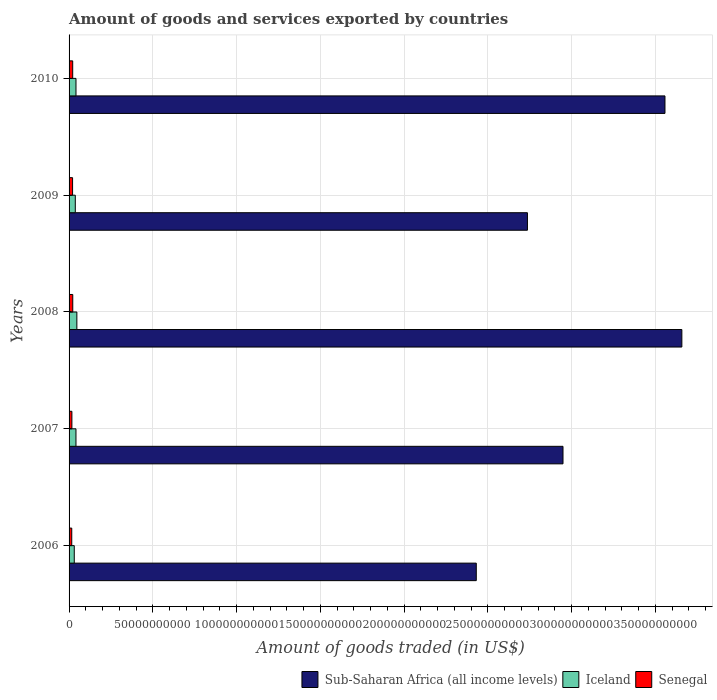How many different coloured bars are there?
Keep it short and to the point. 3. How many groups of bars are there?
Ensure brevity in your answer.  5. Are the number of bars per tick equal to the number of legend labels?
Keep it short and to the point. Yes. Are the number of bars on each tick of the Y-axis equal?
Ensure brevity in your answer.  Yes. How many bars are there on the 1st tick from the top?
Ensure brevity in your answer.  3. How many bars are there on the 5th tick from the bottom?
Offer a terse response. 3. What is the label of the 3rd group of bars from the top?
Make the answer very short. 2008. In how many cases, is the number of bars for a given year not equal to the number of legend labels?
Offer a very short reply. 0. What is the total amount of goods and services exported in Senegal in 2007?
Your response must be concise. 1.68e+09. Across all years, what is the maximum total amount of goods and services exported in Sub-Saharan Africa (all income levels)?
Offer a terse response. 3.66e+11. Across all years, what is the minimum total amount of goods and services exported in Iceland?
Give a very brief answer. 3.10e+09. What is the total total amount of goods and services exported in Senegal in the graph?
Keep it short and to the point. 9.75e+09. What is the difference between the total amount of goods and services exported in Iceland in 2009 and that in 2010?
Keep it short and to the point. -4.06e+08. What is the difference between the total amount of goods and services exported in Senegal in 2006 and the total amount of goods and services exported in Sub-Saharan Africa (all income levels) in 2007?
Give a very brief answer. -2.93e+11. What is the average total amount of goods and services exported in Senegal per year?
Make the answer very short. 1.95e+09. In the year 2010, what is the difference between the total amount of goods and services exported in Iceland and total amount of goods and services exported in Senegal?
Your answer should be very brief. 1.96e+09. In how many years, is the total amount of goods and services exported in Iceland greater than 20000000000 US$?
Ensure brevity in your answer.  0. What is the ratio of the total amount of goods and services exported in Senegal in 2006 to that in 2008?
Provide a succinct answer. 0.72. Is the total amount of goods and services exported in Iceland in 2009 less than that in 2010?
Ensure brevity in your answer.  Yes. What is the difference between the highest and the second highest total amount of goods and services exported in Senegal?
Offer a terse response. 4.41e+07. What is the difference between the highest and the lowest total amount of goods and services exported in Iceland?
Offer a very short reply. 1.55e+09. In how many years, is the total amount of goods and services exported in Senegal greater than the average total amount of goods and services exported in Senegal taken over all years?
Give a very brief answer. 3. Is the sum of the total amount of goods and services exported in Senegal in 2008 and 2010 greater than the maximum total amount of goods and services exported in Sub-Saharan Africa (all income levels) across all years?
Offer a very short reply. No. What does the 3rd bar from the top in 2008 represents?
Offer a very short reply. Sub-Saharan Africa (all income levels). What does the 2nd bar from the bottom in 2010 represents?
Provide a succinct answer. Iceland. Is it the case that in every year, the sum of the total amount of goods and services exported in Sub-Saharan Africa (all income levels) and total amount of goods and services exported in Iceland is greater than the total amount of goods and services exported in Senegal?
Give a very brief answer. Yes. How many bars are there?
Your response must be concise. 15. Are all the bars in the graph horizontal?
Provide a succinct answer. Yes. How many years are there in the graph?
Your response must be concise. 5. Does the graph contain any zero values?
Keep it short and to the point. No. Does the graph contain grids?
Provide a succinct answer. Yes. Where does the legend appear in the graph?
Ensure brevity in your answer.  Bottom right. How many legend labels are there?
Make the answer very short. 3. How are the legend labels stacked?
Offer a terse response. Horizontal. What is the title of the graph?
Give a very brief answer. Amount of goods and services exported by countries. What is the label or title of the X-axis?
Provide a short and direct response. Amount of goods traded (in US$). What is the Amount of goods traded (in US$) of Sub-Saharan Africa (all income levels) in 2006?
Your answer should be very brief. 2.43e+11. What is the Amount of goods traded (in US$) of Iceland in 2006?
Your answer should be compact. 3.10e+09. What is the Amount of goods traded (in US$) in Senegal in 2006?
Your response must be concise. 1.60e+09. What is the Amount of goods traded (in US$) in Sub-Saharan Africa (all income levels) in 2007?
Ensure brevity in your answer.  2.95e+11. What is the Amount of goods traded (in US$) in Iceland in 2007?
Your response must be concise. 4.12e+09. What is the Amount of goods traded (in US$) of Senegal in 2007?
Your answer should be compact. 1.68e+09. What is the Amount of goods traded (in US$) in Sub-Saharan Africa (all income levels) in 2008?
Keep it short and to the point. 3.66e+11. What is the Amount of goods traded (in US$) in Iceland in 2008?
Your response must be concise. 4.65e+09. What is the Amount of goods traded (in US$) of Senegal in 2008?
Your response must be concise. 2.21e+09. What is the Amount of goods traded (in US$) of Sub-Saharan Africa (all income levels) in 2009?
Your answer should be compact. 2.74e+11. What is the Amount of goods traded (in US$) in Iceland in 2009?
Your response must be concise. 3.72e+09. What is the Amount of goods traded (in US$) in Senegal in 2009?
Ensure brevity in your answer.  2.10e+09. What is the Amount of goods traded (in US$) of Sub-Saharan Africa (all income levels) in 2010?
Make the answer very short. 3.56e+11. What is the Amount of goods traded (in US$) in Iceland in 2010?
Ensure brevity in your answer.  4.12e+09. What is the Amount of goods traded (in US$) in Senegal in 2010?
Offer a terse response. 2.16e+09. Across all years, what is the maximum Amount of goods traded (in US$) in Sub-Saharan Africa (all income levels)?
Keep it short and to the point. 3.66e+11. Across all years, what is the maximum Amount of goods traded (in US$) in Iceland?
Offer a very short reply. 4.65e+09. Across all years, what is the maximum Amount of goods traded (in US$) in Senegal?
Make the answer very short. 2.21e+09. Across all years, what is the minimum Amount of goods traded (in US$) of Sub-Saharan Africa (all income levels)?
Your response must be concise. 2.43e+11. Across all years, what is the minimum Amount of goods traded (in US$) in Iceland?
Give a very brief answer. 3.10e+09. Across all years, what is the minimum Amount of goods traded (in US$) in Senegal?
Offer a terse response. 1.60e+09. What is the total Amount of goods traded (in US$) of Sub-Saharan Africa (all income levels) in the graph?
Your answer should be compact. 1.53e+12. What is the total Amount of goods traded (in US$) of Iceland in the graph?
Your response must be concise. 1.97e+1. What is the total Amount of goods traded (in US$) of Senegal in the graph?
Provide a succinct answer. 9.75e+09. What is the difference between the Amount of goods traded (in US$) of Sub-Saharan Africa (all income levels) in 2006 and that in 2007?
Give a very brief answer. -5.18e+1. What is the difference between the Amount of goods traded (in US$) of Iceland in 2006 and that in 2007?
Your answer should be very brief. -1.02e+09. What is the difference between the Amount of goods traded (in US$) of Senegal in 2006 and that in 2007?
Give a very brief answer. -8.17e+07. What is the difference between the Amount of goods traded (in US$) in Sub-Saharan Africa (all income levels) in 2006 and that in 2008?
Your answer should be compact. -1.23e+11. What is the difference between the Amount of goods traded (in US$) of Iceland in 2006 and that in 2008?
Your answer should be very brief. -1.55e+09. What is the difference between the Amount of goods traded (in US$) in Senegal in 2006 and that in 2008?
Ensure brevity in your answer.  -6.09e+08. What is the difference between the Amount of goods traded (in US$) in Sub-Saharan Africa (all income levels) in 2006 and that in 2009?
Your answer should be very brief. -3.05e+1. What is the difference between the Amount of goods traded (in US$) of Iceland in 2006 and that in 2009?
Your answer should be compact. -6.17e+08. What is the difference between the Amount of goods traded (in US$) of Senegal in 2006 and that in 2009?
Your answer should be compact. -4.97e+08. What is the difference between the Amount of goods traded (in US$) of Sub-Saharan Africa (all income levels) in 2006 and that in 2010?
Make the answer very short. -1.13e+11. What is the difference between the Amount of goods traded (in US$) in Iceland in 2006 and that in 2010?
Offer a terse response. -1.02e+09. What is the difference between the Amount of goods traded (in US$) of Senegal in 2006 and that in 2010?
Ensure brevity in your answer.  -5.64e+08. What is the difference between the Amount of goods traded (in US$) in Sub-Saharan Africa (all income levels) in 2007 and that in 2008?
Ensure brevity in your answer.  -7.09e+1. What is the difference between the Amount of goods traded (in US$) in Iceland in 2007 and that in 2008?
Keep it short and to the point. -5.34e+08. What is the difference between the Amount of goods traded (in US$) of Senegal in 2007 and that in 2008?
Your answer should be compact. -5.27e+08. What is the difference between the Amount of goods traded (in US$) in Sub-Saharan Africa (all income levels) in 2007 and that in 2009?
Offer a terse response. 2.12e+1. What is the difference between the Amount of goods traded (in US$) in Iceland in 2007 and that in 2009?
Your answer should be very brief. 4.02e+08. What is the difference between the Amount of goods traded (in US$) of Senegal in 2007 and that in 2009?
Give a very brief answer. -4.15e+08. What is the difference between the Amount of goods traded (in US$) of Sub-Saharan Africa (all income levels) in 2007 and that in 2010?
Offer a very short reply. -6.09e+1. What is the difference between the Amount of goods traded (in US$) in Iceland in 2007 and that in 2010?
Provide a succinct answer. -3.23e+06. What is the difference between the Amount of goods traded (in US$) in Senegal in 2007 and that in 2010?
Keep it short and to the point. -4.83e+08. What is the difference between the Amount of goods traded (in US$) in Sub-Saharan Africa (all income levels) in 2008 and that in 2009?
Keep it short and to the point. 9.22e+1. What is the difference between the Amount of goods traded (in US$) of Iceland in 2008 and that in 2009?
Offer a terse response. 9.37e+08. What is the difference between the Amount of goods traded (in US$) of Senegal in 2008 and that in 2009?
Offer a terse response. 1.12e+08. What is the difference between the Amount of goods traded (in US$) of Sub-Saharan Africa (all income levels) in 2008 and that in 2010?
Provide a succinct answer. 1.01e+1. What is the difference between the Amount of goods traded (in US$) in Iceland in 2008 and that in 2010?
Provide a short and direct response. 5.31e+08. What is the difference between the Amount of goods traded (in US$) of Senegal in 2008 and that in 2010?
Make the answer very short. 4.41e+07. What is the difference between the Amount of goods traded (in US$) of Sub-Saharan Africa (all income levels) in 2009 and that in 2010?
Ensure brevity in your answer.  -8.21e+1. What is the difference between the Amount of goods traded (in US$) in Iceland in 2009 and that in 2010?
Provide a succinct answer. -4.06e+08. What is the difference between the Amount of goods traded (in US$) in Senegal in 2009 and that in 2010?
Make the answer very short. -6.74e+07. What is the difference between the Amount of goods traded (in US$) in Sub-Saharan Africa (all income levels) in 2006 and the Amount of goods traded (in US$) in Iceland in 2007?
Provide a short and direct response. 2.39e+11. What is the difference between the Amount of goods traded (in US$) of Sub-Saharan Africa (all income levels) in 2006 and the Amount of goods traded (in US$) of Senegal in 2007?
Offer a terse response. 2.41e+11. What is the difference between the Amount of goods traded (in US$) in Iceland in 2006 and the Amount of goods traded (in US$) in Senegal in 2007?
Give a very brief answer. 1.42e+09. What is the difference between the Amount of goods traded (in US$) of Sub-Saharan Africa (all income levels) in 2006 and the Amount of goods traded (in US$) of Iceland in 2008?
Ensure brevity in your answer.  2.38e+11. What is the difference between the Amount of goods traded (in US$) in Sub-Saharan Africa (all income levels) in 2006 and the Amount of goods traded (in US$) in Senegal in 2008?
Make the answer very short. 2.41e+11. What is the difference between the Amount of goods traded (in US$) in Iceland in 2006 and the Amount of goods traded (in US$) in Senegal in 2008?
Offer a terse response. 8.90e+08. What is the difference between the Amount of goods traded (in US$) of Sub-Saharan Africa (all income levels) in 2006 and the Amount of goods traded (in US$) of Iceland in 2009?
Offer a terse response. 2.39e+11. What is the difference between the Amount of goods traded (in US$) of Sub-Saharan Africa (all income levels) in 2006 and the Amount of goods traded (in US$) of Senegal in 2009?
Offer a terse response. 2.41e+11. What is the difference between the Amount of goods traded (in US$) of Iceland in 2006 and the Amount of goods traded (in US$) of Senegal in 2009?
Provide a short and direct response. 1.00e+09. What is the difference between the Amount of goods traded (in US$) of Sub-Saharan Africa (all income levels) in 2006 and the Amount of goods traded (in US$) of Iceland in 2010?
Your answer should be compact. 2.39e+11. What is the difference between the Amount of goods traded (in US$) of Sub-Saharan Africa (all income levels) in 2006 and the Amount of goods traded (in US$) of Senegal in 2010?
Your answer should be compact. 2.41e+11. What is the difference between the Amount of goods traded (in US$) of Iceland in 2006 and the Amount of goods traded (in US$) of Senegal in 2010?
Your answer should be very brief. 9.35e+08. What is the difference between the Amount of goods traded (in US$) in Sub-Saharan Africa (all income levels) in 2007 and the Amount of goods traded (in US$) in Iceland in 2008?
Offer a very short reply. 2.90e+11. What is the difference between the Amount of goods traded (in US$) of Sub-Saharan Africa (all income levels) in 2007 and the Amount of goods traded (in US$) of Senegal in 2008?
Your response must be concise. 2.93e+11. What is the difference between the Amount of goods traded (in US$) of Iceland in 2007 and the Amount of goods traded (in US$) of Senegal in 2008?
Give a very brief answer. 1.91e+09. What is the difference between the Amount of goods traded (in US$) in Sub-Saharan Africa (all income levels) in 2007 and the Amount of goods traded (in US$) in Iceland in 2009?
Ensure brevity in your answer.  2.91e+11. What is the difference between the Amount of goods traded (in US$) of Sub-Saharan Africa (all income levels) in 2007 and the Amount of goods traded (in US$) of Senegal in 2009?
Offer a very short reply. 2.93e+11. What is the difference between the Amount of goods traded (in US$) of Iceland in 2007 and the Amount of goods traded (in US$) of Senegal in 2009?
Offer a very short reply. 2.02e+09. What is the difference between the Amount of goods traded (in US$) in Sub-Saharan Africa (all income levels) in 2007 and the Amount of goods traded (in US$) in Iceland in 2010?
Provide a succinct answer. 2.91e+11. What is the difference between the Amount of goods traded (in US$) in Sub-Saharan Africa (all income levels) in 2007 and the Amount of goods traded (in US$) in Senegal in 2010?
Offer a terse response. 2.93e+11. What is the difference between the Amount of goods traded (in US$) of Iceland in 2007 and the Amount of goods traded (in US$) of Senegal in 2010?
Your answer should be very brief. 1.95e+09. What is the difference between the Amount of goods traded (in US$) of Sub-Saharan Africa (all income levels) in 2008 and the Amount of goods traded (in US$) of Iceland in 2009?
Give a very brief answer. 3.62e+11. What is the difference between the Amount of goods traded (in US$) of Sub-Saharan Africa (all income levels) in 2008 and the Amount of goods traded (in US$) of Senegal in 2009?
Provide a succinct answer. 3.64e+11. What is the difference between the Amount of goods traded (in US$) in Iceland in 2008 and the Amount of goods traded (in US$) in Senegal in 2009?
Give a very brief answer. 2.56e+09. What is the difference between the Amount of goods traded (in US$) of Sub-Saharan Africa (all income levels) in 2008 and the Amount of goods traded (in US$) of Iceland in 2010?
Give a very brief answer. 3.62e+11. What is the difference between the Amount of goods traded (in US$) in Sub-Saharan Africa (all income levels) in 2008 and the Amount of goods traded (in US$) in Senegal in 2010?
Ensure brevity in your answer.  3.64e+11. What is the difference between the Amount of goods traded (in US$) in Iceland in 2008 and the Amount of goods traded (in US$) in Senegal in 2010?
Give a very brief answer. 2.49e+09. What is the difference between the Amount of goods traded (in US$) in Sub-Saharan Africa (all income levels) in 2009 and the Amount of goods traded (in US$) in Iceland in 2010?
Provide a short and direct response. 2.69e+11. What is the difference between the Amount of goods traded (in US$) in Sub-Saharan Africa (all income levels) in 2009 and the Amount of goods traded (in US$) in Senegal in 2010?
Provide a succinct answer. 2.71e+11. What is the difference between the Amount of goods traded (in US$) in Iceland in 2009 and the Amount of goods traded (in US$) in Senegal in 2010?
Give a very brief answer. 1.55e+09. What is the average Amount of goods traded (in US$) in Sub-Saharan Africa (all income levels) per year?
Keep it short and to the point. 3.07e+11. What is the average Amount of goods traded (in US$) in Iceland per year?
Your response must be concise. 3.94e+09. What is the average Amount of goods traded (in US$) in Senegal per year?
Offer a terse response. 1.95e+09. In the year 2006, what is the difference between the Amount of goods traded (in US$) of Sub-Saharan Africa (all income levels) and Amount of goods traded (in US$) of Iceland?
Keep it short and to the point. 2.40e+11. In the year 2006, what is the difference between the Amount of goods traded (in US$) in Sub-Saharan Africa (all income levels) and Amount of goods traded (in US$) in Senegal?
Provide a succinct answer. 2.41e+11. In the year 2006, what is the difference between the Amount of goods traded (in US$) of Iceland and Amount of goods traded (in US$) of Senegal?
Offer a very short reply. 1.50e+09. In the year 2007, what is the difference between the Amount of goods traded (in US$) of Sub-Saharan Africa (all income levels) and Amount of goods traded (in US$) of Iceland?
Your answer should be compact. 2.91e+11. In the year 2007, what is the difference between the Amount of goods traded (in US$) in Sub-Saharan Africa (all income levels) and Amount of goods traded (in US$) in Senegal?
Keep it short and to the point. 2.93e+11. In the year 2007, what is the difference between the Amount of goods traded (in US$) of Iceland and Amount of goods traded (in US$) of Senegal?
Provide a succinct answer. 2.44e+09. In the year 2008, what is the difference between the Amount of goods traded (in US$) in Sub-Saharan Africa (all income levels) and Amount of goods traded (in US$) in Iceland?
Your response must be concise. 3.61e+11. In the year 2008, what is the difference between the Amount of goods traded (in US$) of Sub-Saharan Africa (all income levels) and Amount of goods traded (in US$) of Senegal?
Your answer should be very brief. 3.64e+11. In the year 2008, what is the difference between the Amount of goods traded (in US$) of Iceland and Amount of goods traded (in US$) of Senegal?
Offer a very short reply. 2.44e+09. In the year 2009, what is the difference between the Amount of goods traded (in US$) in Sub-Saharan Africa (all income levels) and Amount of goods traded (in US$) in Iceland?
Your answer should be very brief. 2.70e+11. In the year 2009, what is the difference between the Amount of goods traded (in US$) in Sub-Saharan Africa (all income levels) and Amount of goods traded (in US$) in Senegal?
Your answer should be very brief. 2.71e+11. In the year 2009, what is the difference between the Amount of goods traded (in US$) of Iceland and Amount of goods traded (in US$) of Senegal?
Ensure brevity in your answer.  1.62e+09. In the year 2010, what is the difference between the Amount of goods traded (in US$) in Sub-Saharan Africa (all income levels) and Amount of goods traded (in US$) in Iceland?
Make the answer very short. 3.52e+11. In the year 2010, what is the difference between the Amount of goods traded (in US$) in Sub-Saharan Africa (all income levels) and Amount of goods traded (in US$) in Senegal?
Offer a terse response. 3.54e+11. In the year 2010, what is the difference between the Amount of goods traded (in US$) in Iceland and Amount of goods traded (in US$) in Senegal?
Your answer should be compact. 1.96e+09. What is the ratio of the Amount of goods traded (in US$) of Sub-Saharan Africa (all income levels) in 2006 to that in 2007?
Ensure brevity in your answer.  0.82. What is the ratio of the Amount of goods traded (in US$) in Iceland in 2006 to that in 2007?
Keep it short and to the point. 0.75. What is the ratio of the Amount of goods traded (in US$) of Senegal in 2006 to that in 2007?
Make the answer very short. 0.95. What is the ratio of the Amount of goods traded (in US$) of Sub-Saharan Africa (all income levels) in 2006 to that in 2008?
Offer a terse response. 0.66. What is the ratio of the Amount of goods traded (in US$) in Iceland in 2006 to that in 2008?
Provide a short and direct response. 0.67. What is the ratio of the Amount of goods traded (in US$) in Senegal in 2006 to that in 2008?
Give a very brief answer. 0.72. What is the ratio of the Amount of goods traded (in US$) of Sub-Saharan Africa (all income levels) in 2006 to that in 2009?
Ensure brevity in your answer.  0.89. What is the ratio of the Amount of goods traded (in US$) of Iceland in 2006 to that in 2009?
Your response must be concise. 0.83. What is the ratio of the Amount of goods traded (in US$) in Senegal in 2006 to that in 2009?
Keep it short and to the point. 0.76. What is the ratio of the Amount of goods traded (in US$) in Sub-Saharan Africa (all income levels) in 2006 to that in 2010?
Your answer should be very brief. 0.68. What is the ratio of the Amount of goods traded (in US$) in Iceland in 2006 to that in 2010?
Ensure brevity in your answer.  0.75. What is the ratio of the Amount of goods traded (in US$) of Senegal in 2006 to that in 2010?
Ensure brevity in your answer.  0.74. What is the ratio of the Amount of goods traded (in US$) of Sub-Saharan Africa (all income levels) in 2007 to that in 2008?
Offer a terse response. 0.81. What is the ratio of the Amount of goods traded (in US$) of Iceland in 2007 to that in 2008?
Your response must be concise. 0.89. What is the ratio of the Amount of goods traded (in US$) in Senegal in 2007 to that in 2008?
Offer a terse response. 0.76. What is the ratio of the Amount of goods traded (in US$) of Sub-Saharan Africa (all income levels) in 2007 to that in 2009?
Provide a short and direct response. 1.08. What is the ratio of the Amount of goods traded (in US$) of Iceland in 2007 to that in 2009?
Your response must be concise. 1.11. What is the ratio of the Amount of goods traded (in US$) of Senegal in 2007 to that in 2009?
Your answer should be compact. 0.8. What is the ratio of the Amount of goods traded (in US$) in Sub-Saharan Africa (all income levels) in 2007 to that in 2010?
Your response must be concise. 0.83. What is the ratio of the Amount of goods traded (in US$) in Iceland in 2007 to that in 2010?
Give a very brief answer. 1. What is the ratio of the Amount of goods traded (in US$) of Senegal in 2007 to that in 2010?
Give a very brief answer. 0.78. What is the ratio of the Amount of goods traded (in US$) of Sub-Saharan Africa (all income levels) in 2008 to that in 2009?
Offer a terse response. 1.34. What is the ratio of the Amount of goods traded (in US$) in Iceland in 2008 to that in 2009?
Keep it short and to the point. 1.25. What is the ratio of the Amount of goods traded (in US$) in Senegal in 2008 to that in 2009?
Make the answer very short. 1.05. What is the ratio of the Amount of goods traded (in US$) of Sub-Saharan Africa (all income levels) in 2008 to that in 2010?
Offer a terse response. 1.03. What is the ratio of the Amount of goods traded (in US$) in Iceland in 2008 to that in 2010?
Ensure brevity in your answer.  1.13. What is the ratio of the Amount of goods traded (in US$) of Senegal in 2008 to that in 2010?
Ensure brevity in your answer.  1.02. What is the ratio of the Amount of goods traded (in US$) of Sub-Saharan Africa (all income levels) in 2009 to that in 2010?
Provide a succinct answer. 0.77. What is the ratio of the Amount of goods traded (in US$) of Iceland in 2009 to that in 2010?
Your answer should be very brief. 0.9. What is the ratio of the Amount of goods traded (in US$) of Senegal in 2009 to that in 2010?
Provide a succinct answer. 0.97. What is the difference between the highest and the second highest Amount of goods traded (in US$) in Sub-Saharan Africa (all income levels)?
Keep it short and to the point. 1.01e+1. What is the difference between the highest and the second highest Amount of goods traded (in US$) in Iceland?
Offer a terse response. 5.31e+08. What is the difference between the highest and the second highest Amount of goods traded (in US$) of Senegal?
Provide a short and direct response. 4.41e+07. What is the difference between the highest and the lowest Amount of goods traded (in US$) of Sub-Saharan Africa (all income levels)?
Your answer should be compact. 1.23e+11. What is the difference between the highest and the lowest Amount of goods traded (in US$) of Iceland?
Offer a terse response. 1.55e+09. What is the difference between the highest and the lowest Amount of goods traded (in US$) in Senegal?
Your answer should be compact. 6.09e+08. 